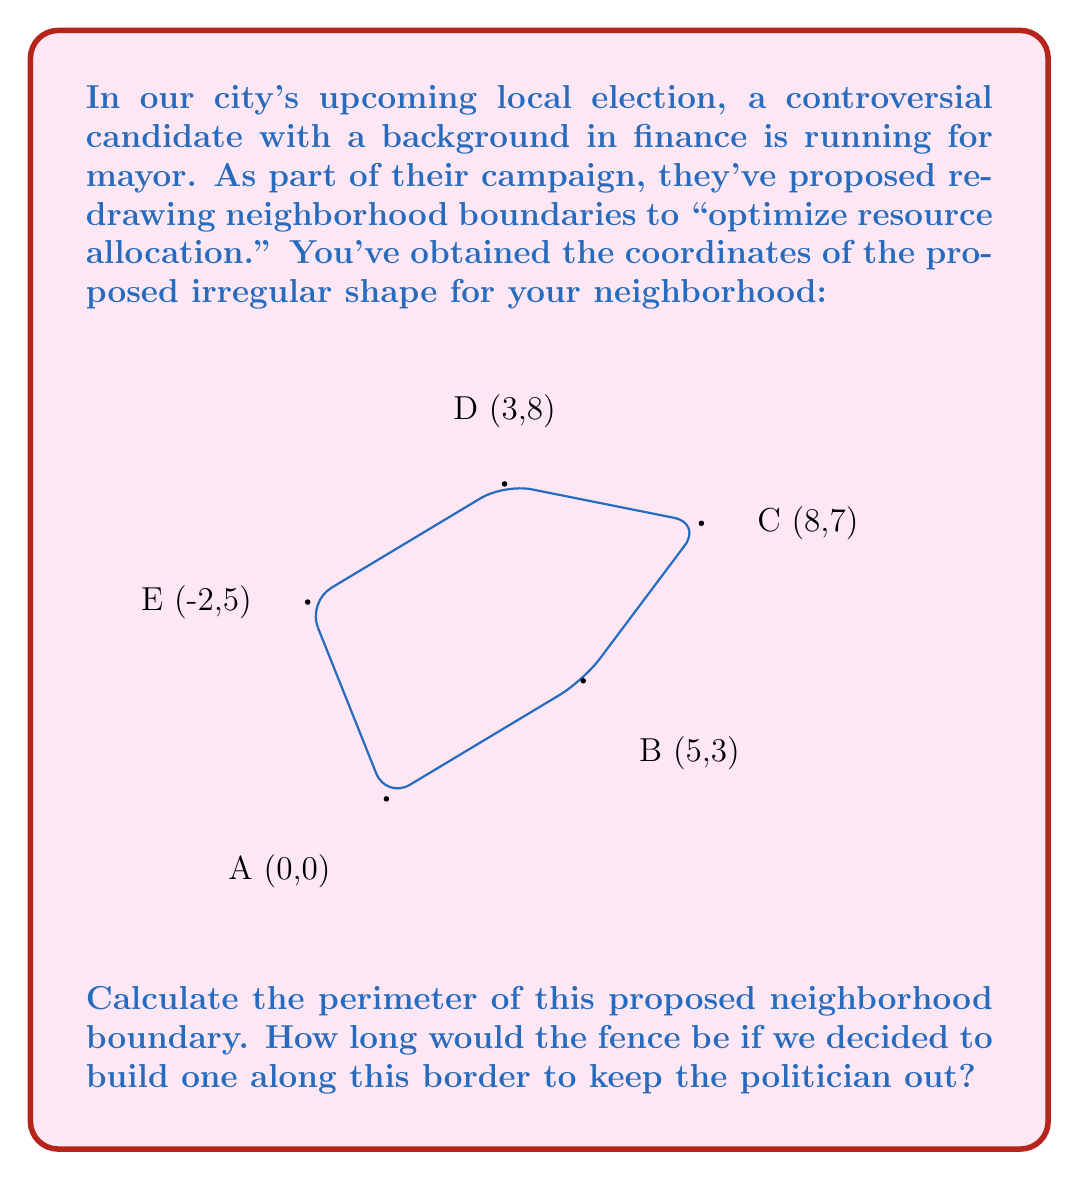Solve this math problem. To calculate the perimeter of this irregular shape, we need to sum the distances between each pair of consecutive points. We can use the distance formula between two points $(x_1, y_1)$ and $(x_2, y_2)$:

$$d = \sqrt{(x_2 - x_1)^2 + (y_2 - y_1)^2}$$

Let's calculate each segment:

1. A to B: $d_{AB} = \sqrt{(5-0)^2 + (3-0)^2} = \sqrt{25 + 9} = \sqrt{34}$

2. B to C: $d_{BC} = \sqrt{(8-5)^2 + (7-3)^2} = \sqrt{9 + 16} = 5$

3. C to D: $d_{CD} = \sqrt{(3-8)^2 + (8-7)^2} = \sqrt{25 + 1} = \sqrt{26}$

4. D to E: $d_{DE} = \sqrt{(-2-3)^2 + (5-8)^2} = \sqrt{25 + 9} = \sqrt{34}$

5. E to A: $d_{EA} = \sqrt{(0+2)^2 + (0-5)^2} = \sqrt{4 + 25} = \sqrt{29}$

Now, we sum all these distances:

$$\text{Perimeter} = \sqrt{34} + 5 + \sqrt{26} + \sqrt{34} + \sqrt{29}$$

This is the exact perimeter. If we want a decimal approximation:

$$\text{Perimeter} \approx 5.83 + 5 + 5.10 + 5.83 + 5.39 \approx 27.15$$

So, the perimeter of the proposed neighborhood is approximately 27.15 units (e.g., kilometers or miles, depending on the scale used).
Answer: $\sqrt{34} + 5 + \sqrt{26} + \sqrt{34} + \sqrt{29}$ units (exact) or approximately 27.15 units 